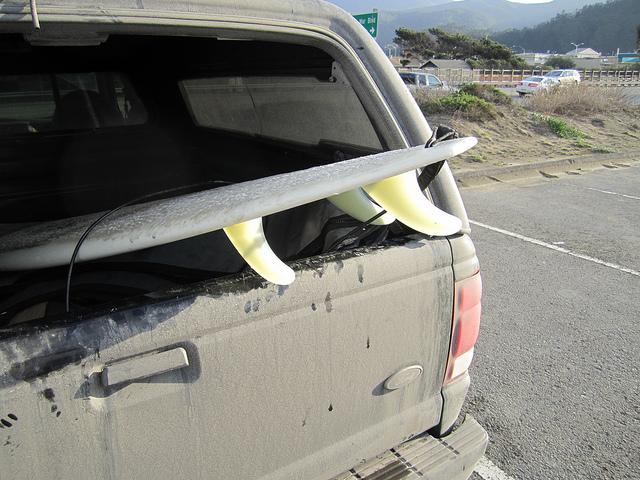Is there a surfboard in the vehicle?
Quick response, please. Yes. Is the vehicle clean or dirty?
Answer briefly. Dirty. Is the window down on the back of this vehicle?
Be succinct. Yes. 